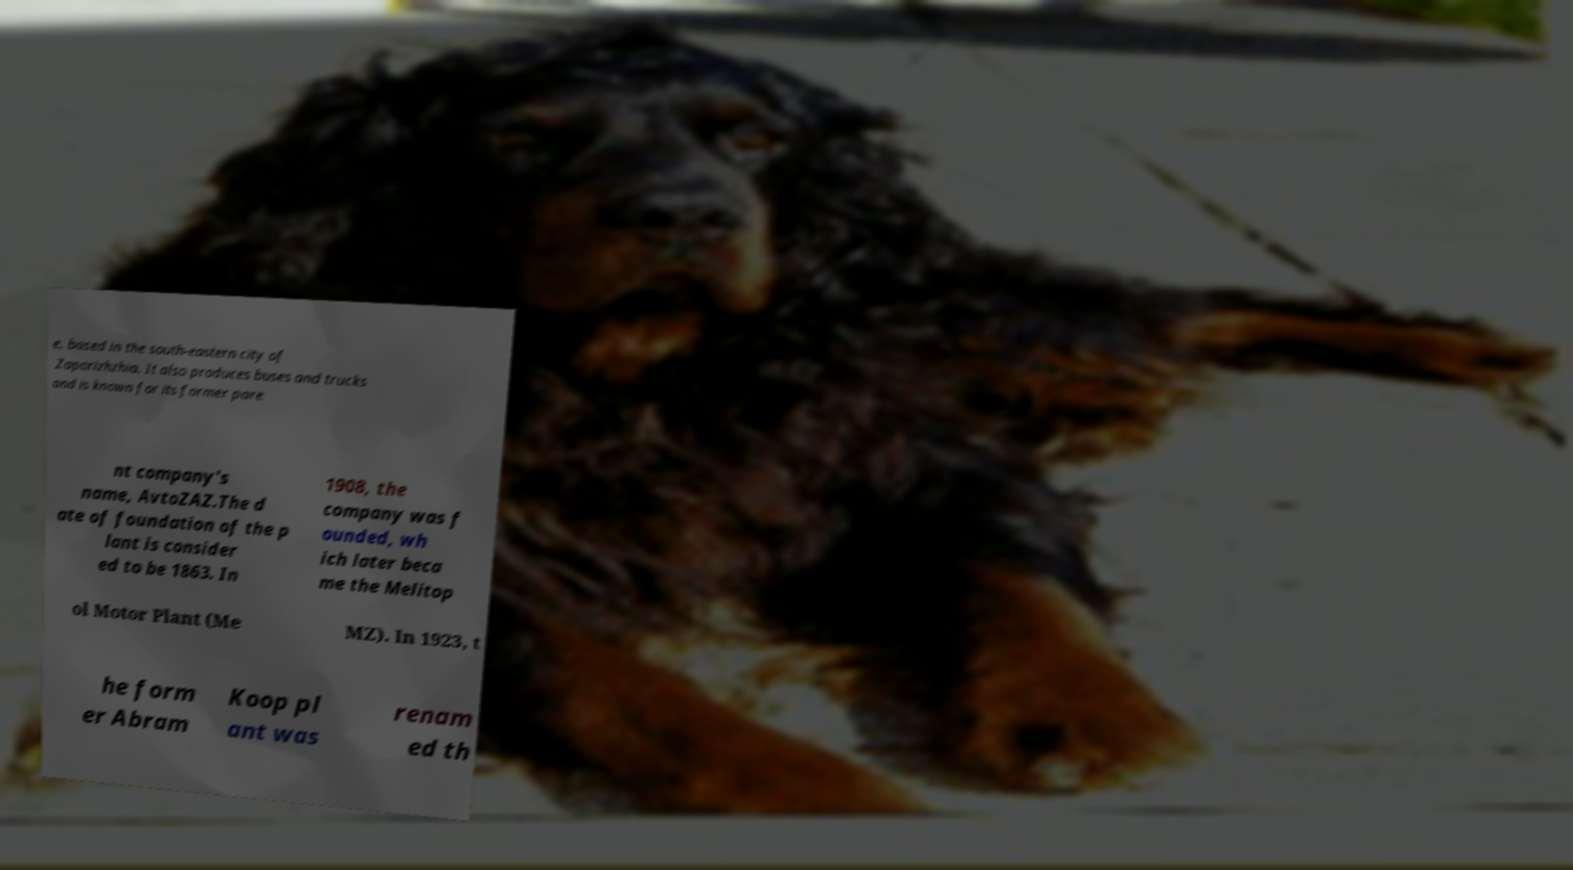What messages or text are displayed in this image? I need them in a readable, typed format. e, based in the south-eastern city of Zaporizhzhia. It also produces buses and trucks and is known for its former pare nt company's name, AvtoZAZ.The d ate of foundation of the p lant is consider ed to be 1863. In 1908, the company was f ounded, wh ich later beca me the Melitop ol Motor Plant (Me MZ). In 1923, t he form er Abram Koop pl ant was renam ed th 